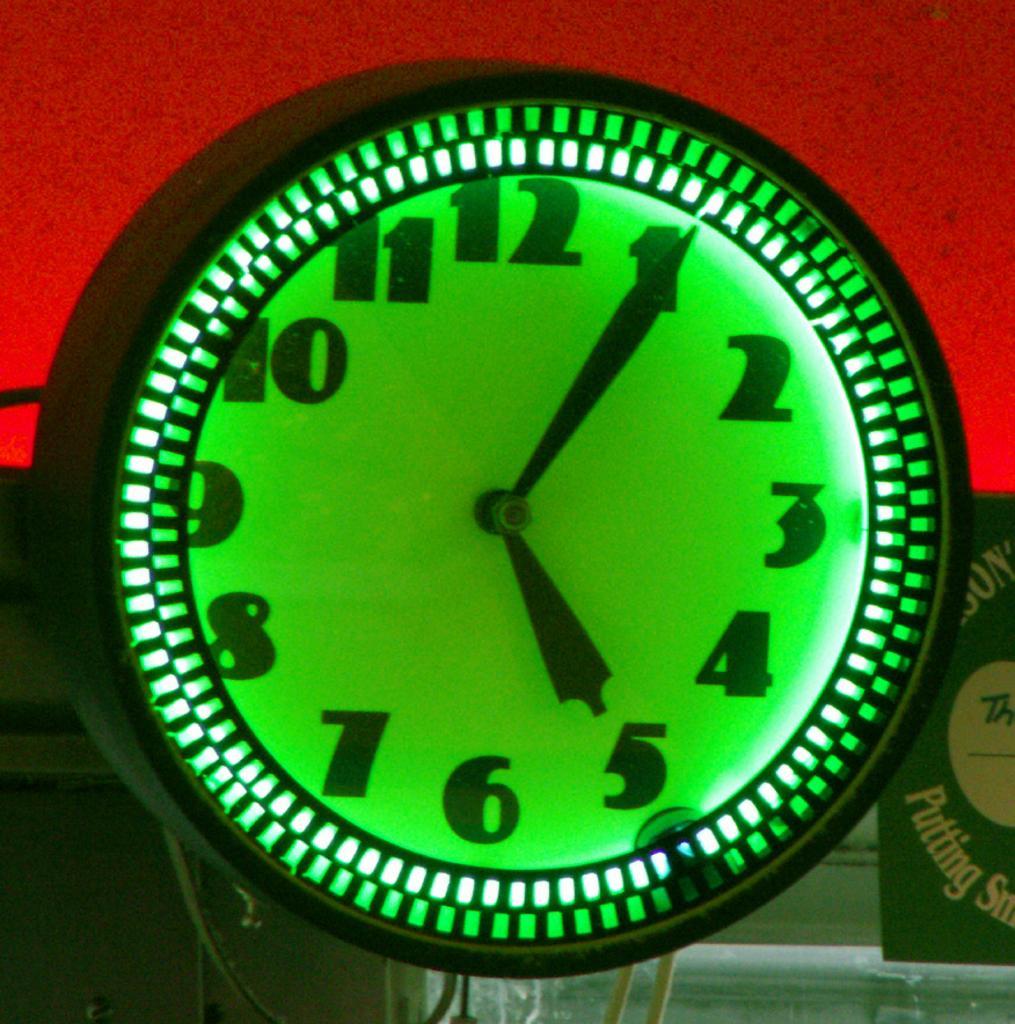How would you summarize this image in a sentence or two? In this picture we can see clock, poster, cables and object. In the background of the image it is red. 